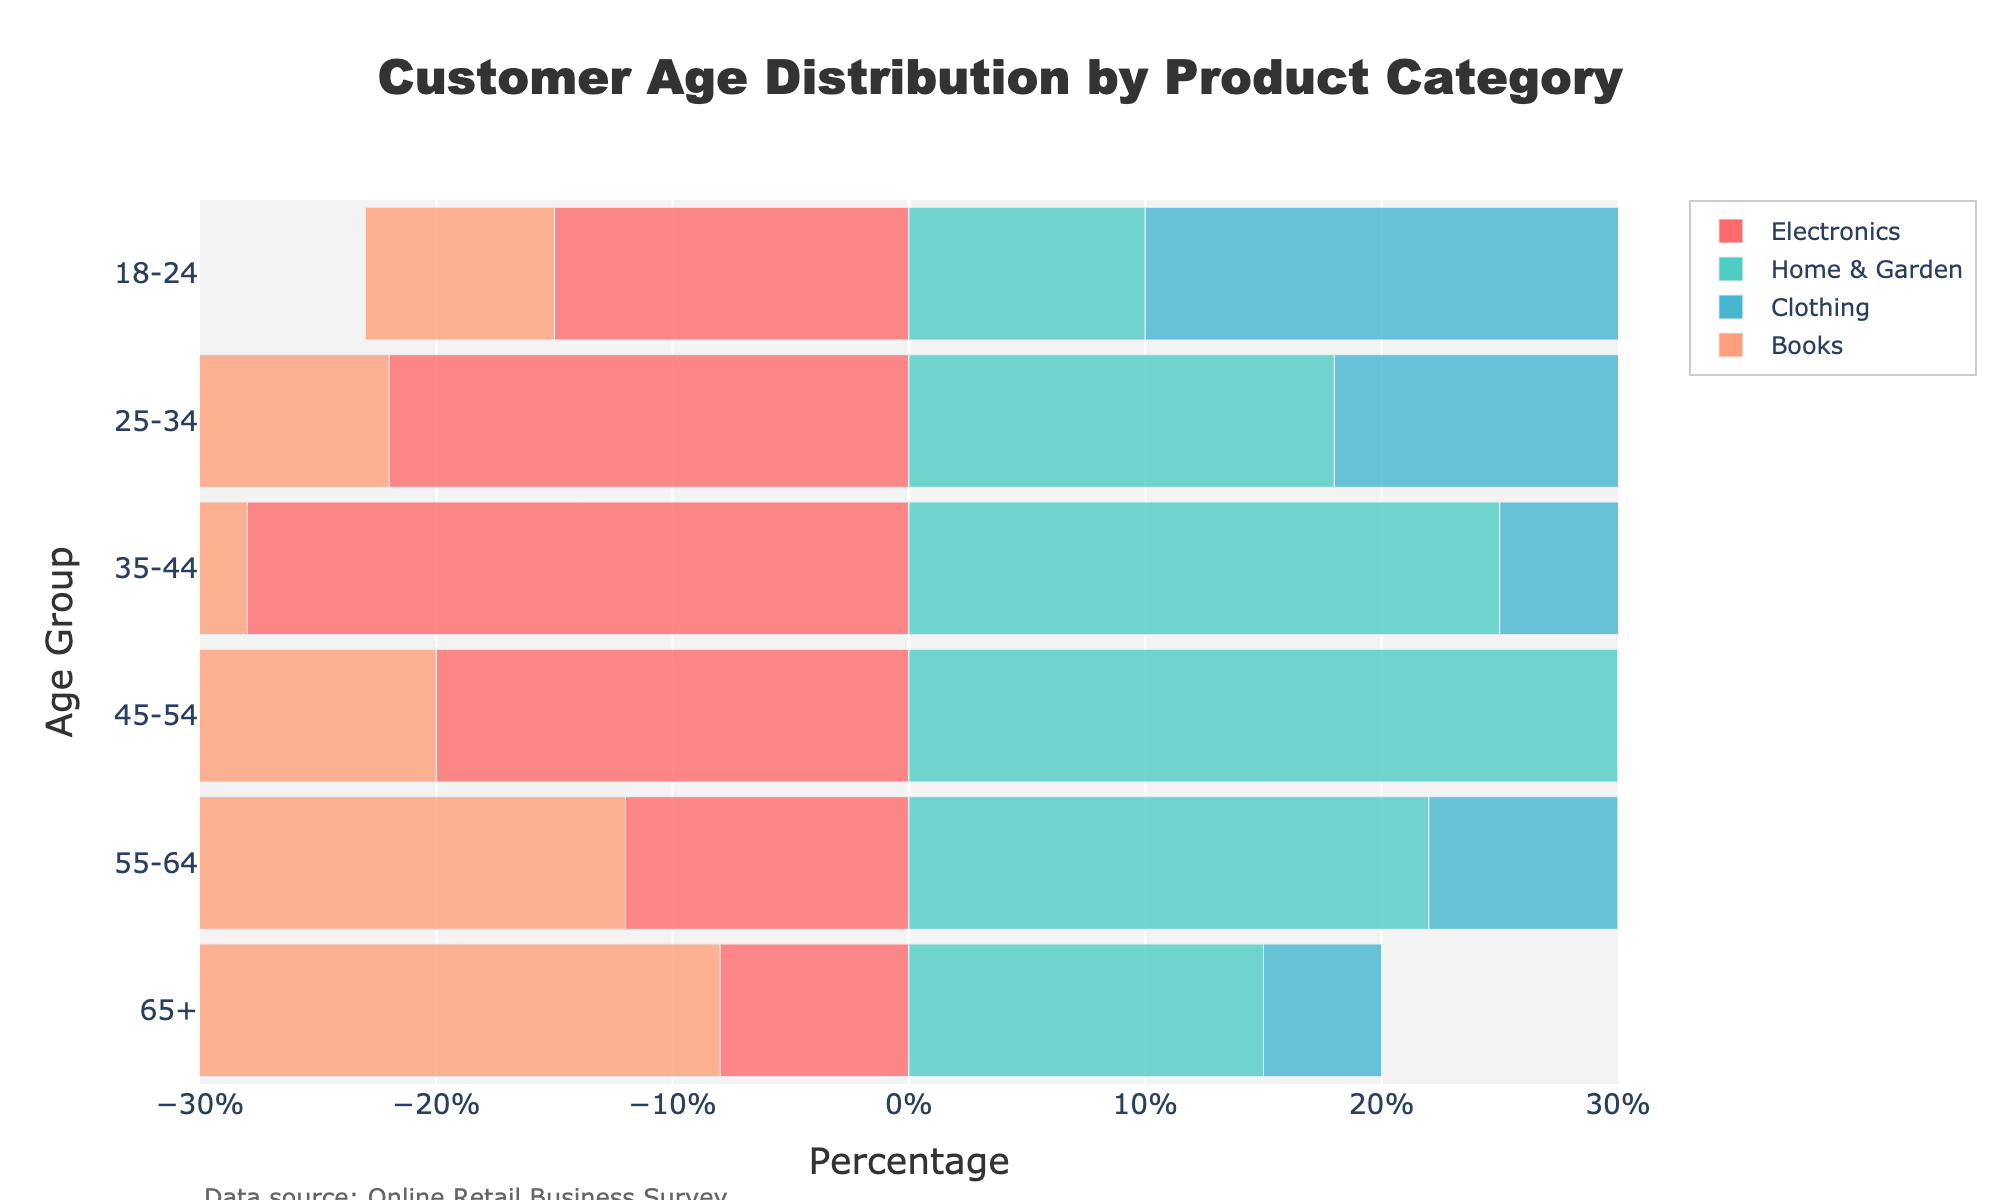What is the title of the figure? The title of the figure is typically the largest text displayed prominently at the top. Here, it reads "Customer Age Distribution by Product Category".
Answer: Customer Age Distribution by Product Category Which age group has the highest proportion of Electronics customers? To determine this, you need to look for the age group with the longest bar pointing to the left under the 'Electronics' category. The 35-44 age group has the longest bar.
Answer: 35-44 How does the percentage of Clothing customers aged 25-34 compare to those aged 18-24? Compare the lengths of the bars for the 'Clothing' category at these age groups. 25-34 has a bar length of 30, while 18-24 has a bar length of 25.
Answer: 25-34 has a higher percentage than 18-24 What is the percentage difference between Home & Garden customers aged 45-54 and 55-64? Look at the lengths of the bars for 'Home & Garden' in these age groups. The bars show 30% for 45-54 and 22% for 55-64. The difference is 30% - 22% = 8%.
Answer: 8% Which product category has the least number of customers aged 65+? Find the category with the shortest bar at the 65+ age group. The 'Books' category has the shortest bar at this age group with -25%.
Answer: Books In which age group is the proportion of Books customers the highest? Look for the age group with the longest bar pointing to the left under the 'Books' category. The 65+ age group has the longest bar.
Answer: 65+ What is the combined percentage of Home & Garden customers in the age groups 18-24 and 25-34? For the 'Home & Garden' category, add the percentages in these age groups. 10% for 18-24 and 18% for 25-34. The sum is 10% + 18% = 28%.
Answer: 28% Does the proportion of Electronics customers increase or decrease with age? Examine the lengths of bars for the 'Electronics' category across all age groups. The lengths decrease from 18-24 to 65+.
Answer: Decrease Which age group has approximately equal percentages of customers in both Electronics and Clothing? Compare the bars for 'Electronics' and 'Clothing' for all age groups. For the 45-54 age group, 'Electronics' is -20% and 'Clothing' is 15%, which are roughly equal in magnitude but opposite in direction.
Answer: 45-54 